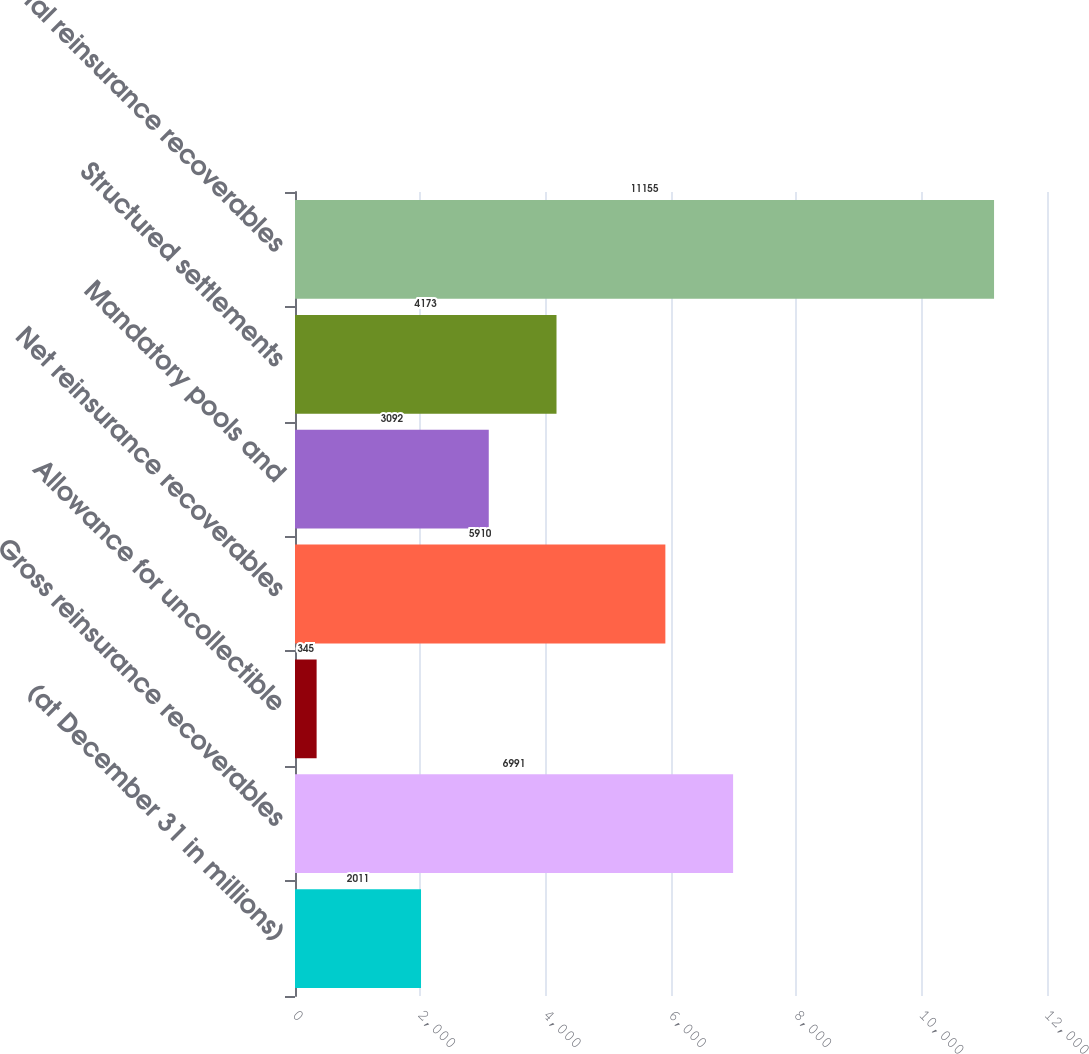<chart> <loc_0><loc_0><loc_500><loc_500><bar_chart><fcel>(at December 31 in millions)<fcel>Gross reinsurance recoverables<fcel>Allowance for uncollectible<fcel>Net reinsurance recoverables<fcel>Mandatory pools and<fcel>Structured settlements<fcel>Total reinsurance recoverables<nl><fcel>2011<fcel>6991<fcel>345<fcel>5910<fcel>3092<fcel>4173<fcel>11155<nl></chart> 